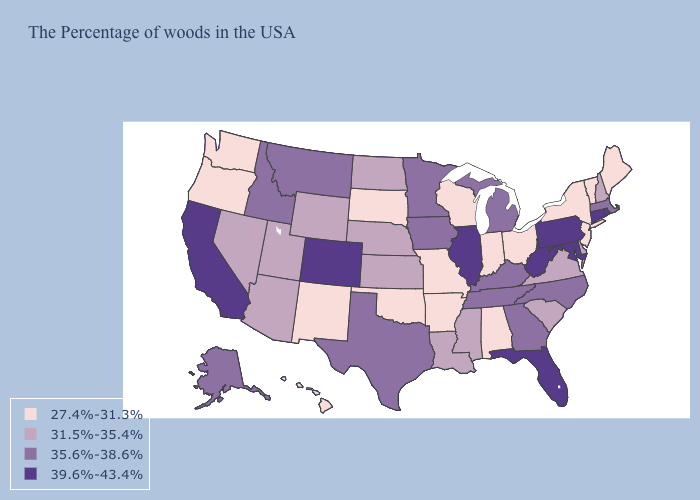Does Iowa have the highest value in the USA?
Be succinct. No. Which states have the highest value in the USA?
Write a very short answer. Rhode Island, Connecticut, Maryland, Pennsylvania, West Virginia, Florida, Illinois, Colorado, California. Name the states that have a value in the range 35.6%-38.6%?
Quick response, please. Massachusetts, North Carolina, Georgia, Michigan, Kentucky, Tennessee, Minnesota, Iowa, Texas, Montana, Idaho, Alaska. What is the value of Missouri?
Quick response, please. 27.4%-31.3%. Among the states that border Missouri , which have the highest value?
Write a very short answer. Illinois. Does California have the highest value in the USA?
Give a very brief answer. Yes. Does Michigan have the highest value in the MidWest?
Concise answer only. No. What is the highest value in the MidWest ?
Keep it brief. 39.6%-43.4%. What is the value of Maine?
Give a very brief answer. 27.4%-31.3%. Does Wisconsin have the lowest value in the USA?
Quick response, please. Yes. What is the lowest value in the Northeast?
Quick response, please. 27.4%-31.3%. Does the map have missing data?
Concise answer only. No. What is the value of Utah?
Keep it brief. 31.5%-35.4%. Does Massachusetts have a higher value than Mississippi?
Answer briefly. Yes. Is the legend a continuous bar?
Short answer required. No. 